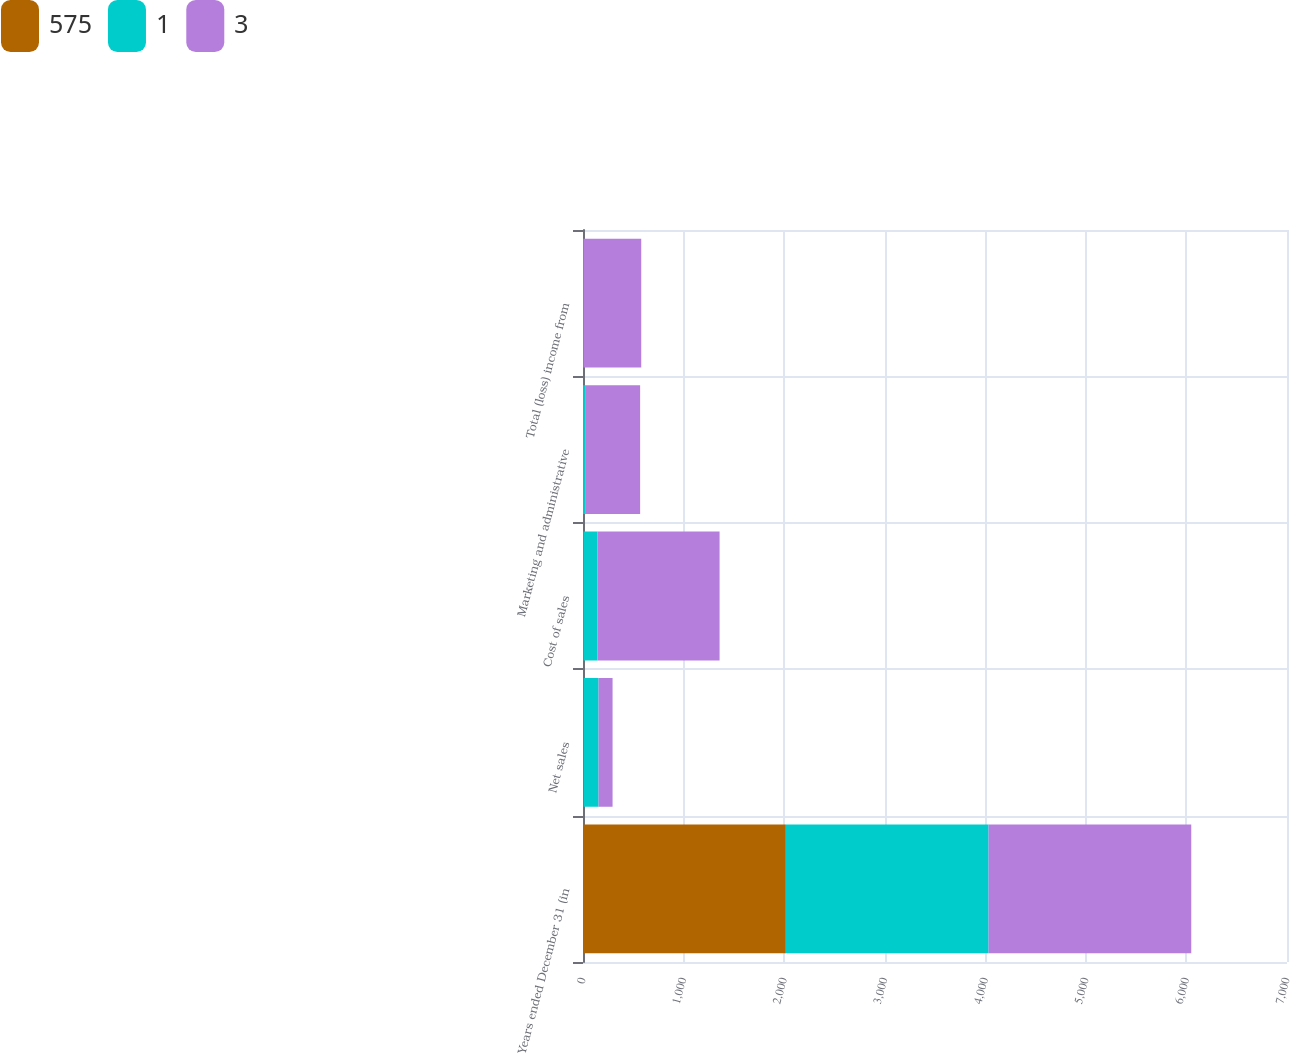Convert chart to OTSL. <chart><loc_0><loc_0><loc_500><loc_500><stacked_bar_chart><ecel><fcel>Years ended December 31 (in<fcel>Net sales<fcel>Cost of sales<fcel>Marketing and administrative<fcel>Total (loss) income from<nl><fcel>575<fcel>2017<fcel>7<fcel>5<fcel>1<fcel>3<nl><fcel>1<fcel>2016<fcel>148<fcel>139<fcel>20<fcel>1<nl><fcel>3<fcel>2015<fcel>139<fcel>1214<fcel>547<fcel>575<nl></chart> 